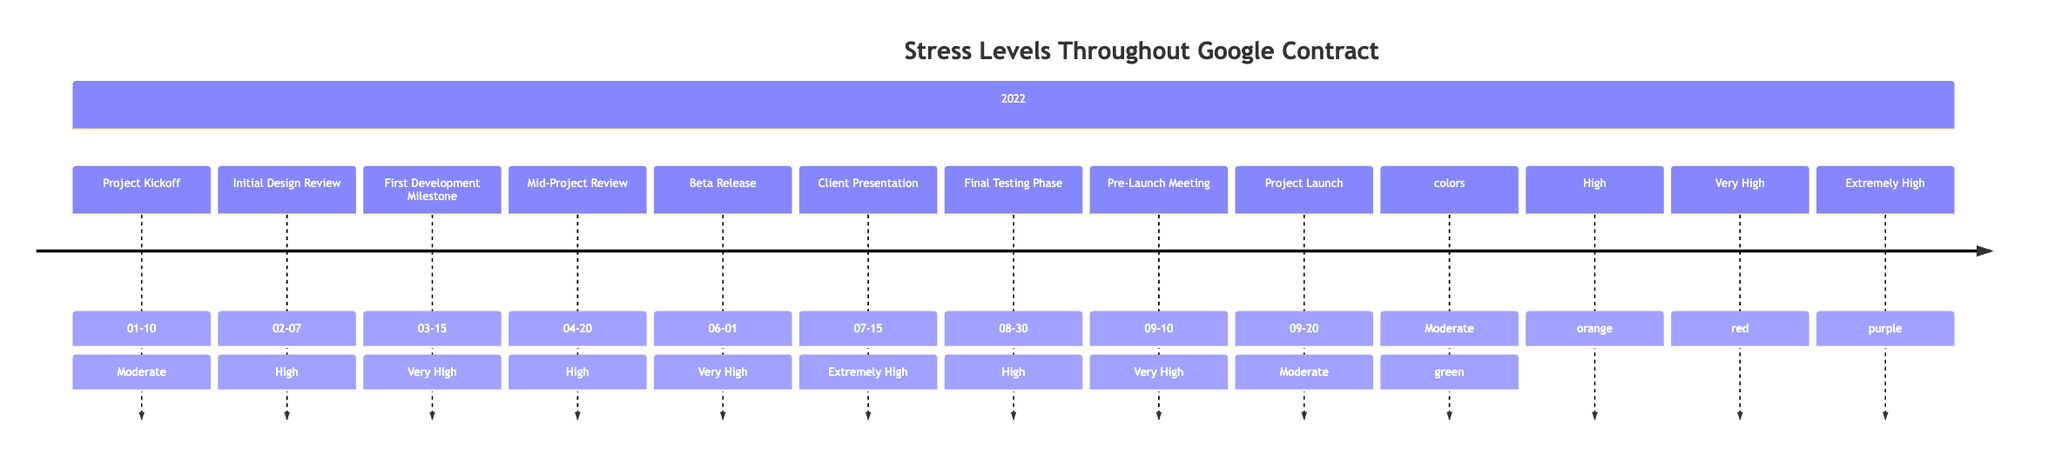What was the stress level during the Beta Release? In the diagram, the stress level on the date of the Beta Release (June 1, 2022) is indicated as "Very High." Therefore, by locating the corresponding event along the timeline, one can easily identify the stress level associated with that date.
Answer: Very High What event occurred on March 15, 2022? Looking at the timeline, March 15, 2022, corresponds to the event labeled "First Development Milestone." This can be confirmed by identifying that date on the timeline and noting the associated event.
Answer: First Development Milestone How many major events are categorized as "High" stress levels? The diagram shows three events that are specifically categorized under the "High" stress level, which can be counted by visually examining each event’s stress classification within the timeline.
Answer: Three Which event had the highest stress level? Analyzing the timeline, the event with the highest stress level is the "Client Presentation," which has an "Extremely High" designation. This entails scanning through the stress levels of all events and identifying the maximum.
Answer: Client Presentation What was the stress level before the Project Launch? Just before the Project Launch on September 20, 2022, the stress level associated with the "Pre-Launch Meeting" on September 10, 2022, is "Very High." By tracing backward in the timeline from the launch event, this stress level can be determined.
Answer: Very High How did the stress levels change from the Mid-Project Review to the Beta Release? The stress level during the Mid-Project Review on April 20, 2022, is "High," and it increased to "Very High" during the Beta Release on June 1, 2022. By comparing these two events on the timeline, one can observe the shift from "High" to "Very High."
Answer: Increased What event takes place after the Initial Design Review? Following the "Initial Design Review" on February 7, 2022, the next event in sequence is the "First Development Milestone" on March 15, 2022. This can be verified by following the order of events as laid out on the timeline.
Answer: First Development Milestone Which event has the lowest stress level? The event with the lowest stress level is the "Project Launch" on September 20, 2022, which is classified as "Moderate." By reviewing all events, this can be confirmed as the minimum level.
Answer: Project Launch What stress level characterized the Client Presentation? The Client Presentation that occurred on July 15, 2022, is marked with an "Extremely High" stress level on the timeline. This can be determined by checking the stress categorization for that specific event.
Answer: Extremely High 